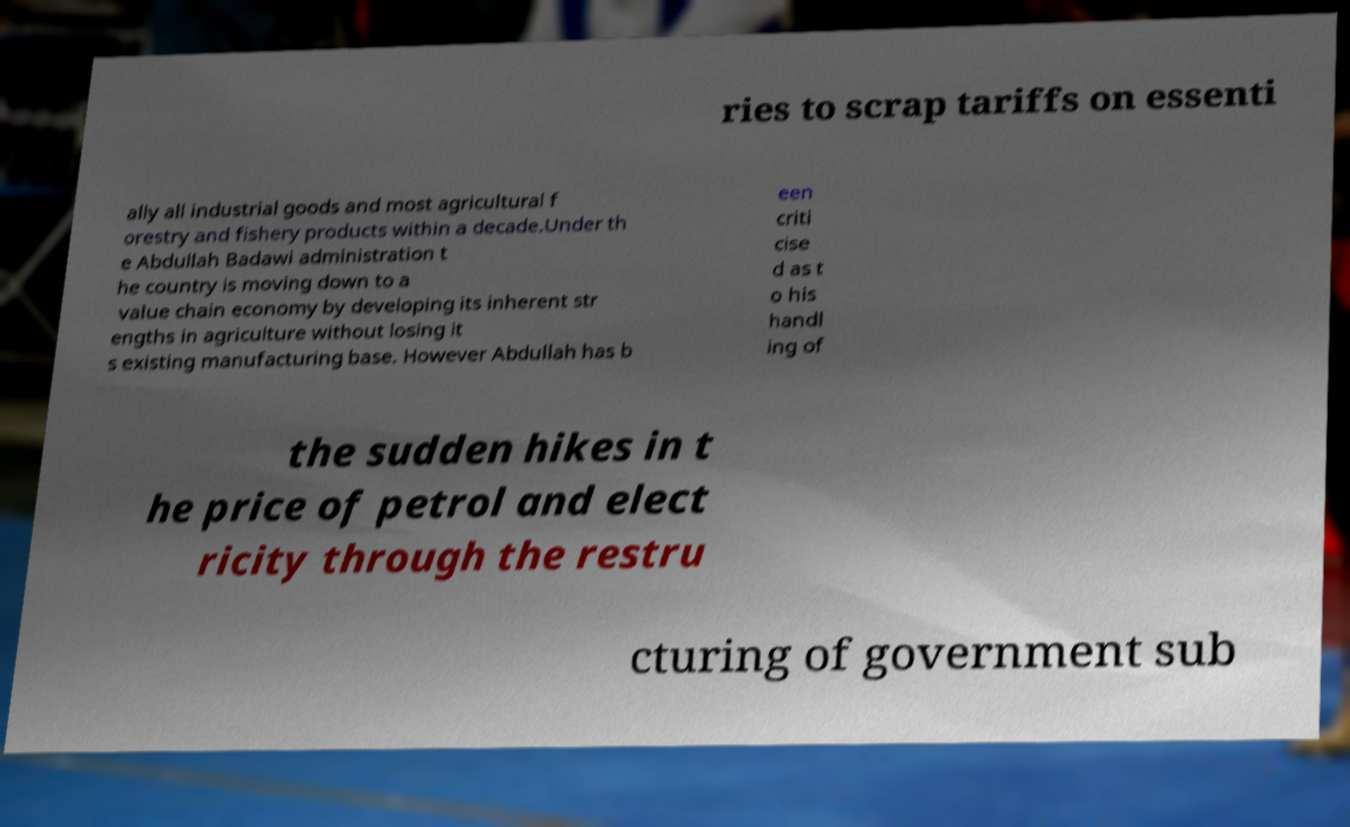I need the written content from this picture converted into text. Can you do that? ries to scrap tariffs on essenti ally all industrial goods and most agricultural f orestry and fishery products within a decade.Under th e Abdullah Badawi administration t he country is moving down to a value chain economy by developing its inherent str engths in agriculture without losing it s existing manufacturing base. However Abdullah has b een criti cise d as t o his handl ing of the sudden hikes in t he price of petrol and elect ricity through the restru cturing of government sub 